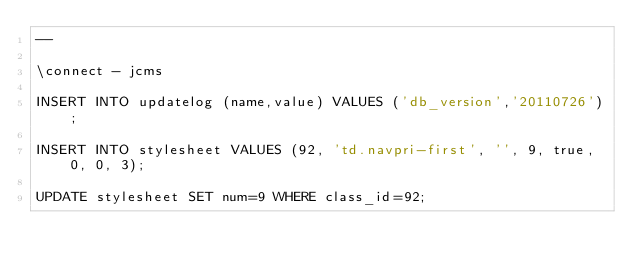<code> <loc_0><loc_0><loc_500><loc_500><_SQL_>--

\connect - jcms

INSERT INTO updatelog (name,value) VALUES ('db_version','20110726');

INSERT INTO stylesheet VALUES (92, 'td.navpri-first', '', 9, true, 0, 0, 3);

UPDATE stylesheet SET num=9 WHERE class_id=92;
</code> 